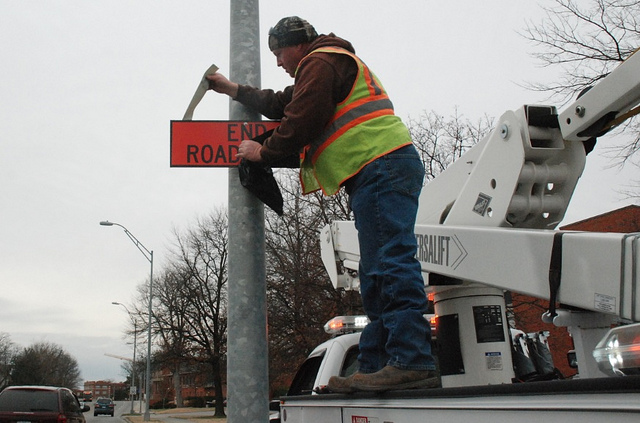Please transcribe the text in this image. END ROAD ERSALIFT 